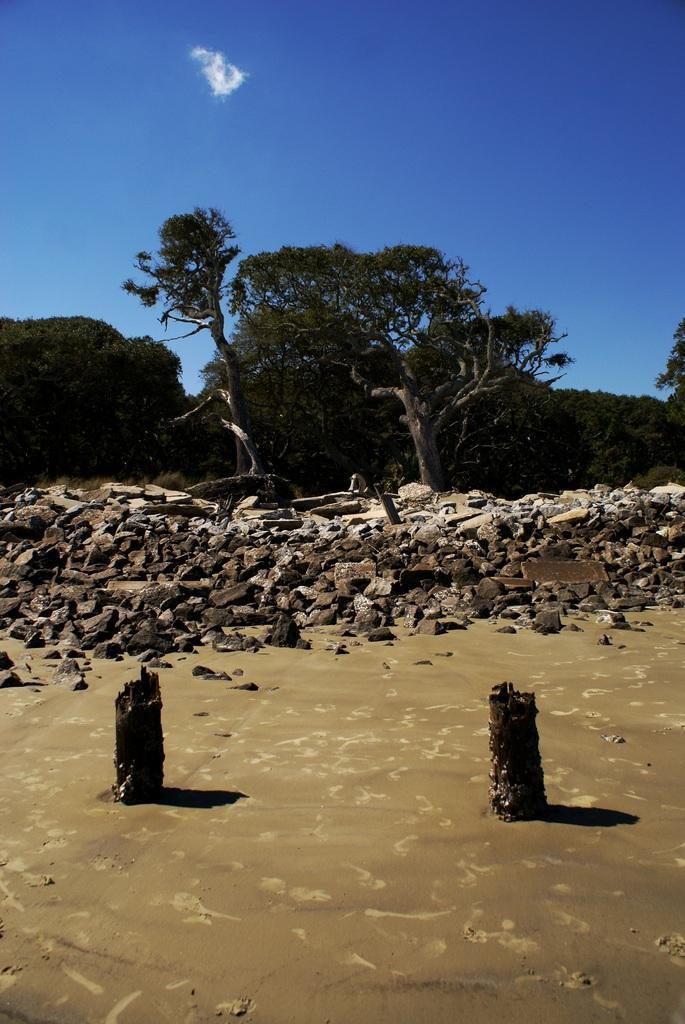In one or two sentences, can you explain what this image depicts? In this image, we can see mud and there are some small stones, we can see some green color trees, at the top there is a blue color sky. 